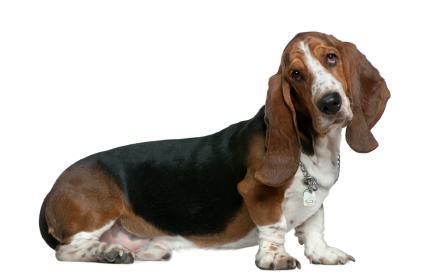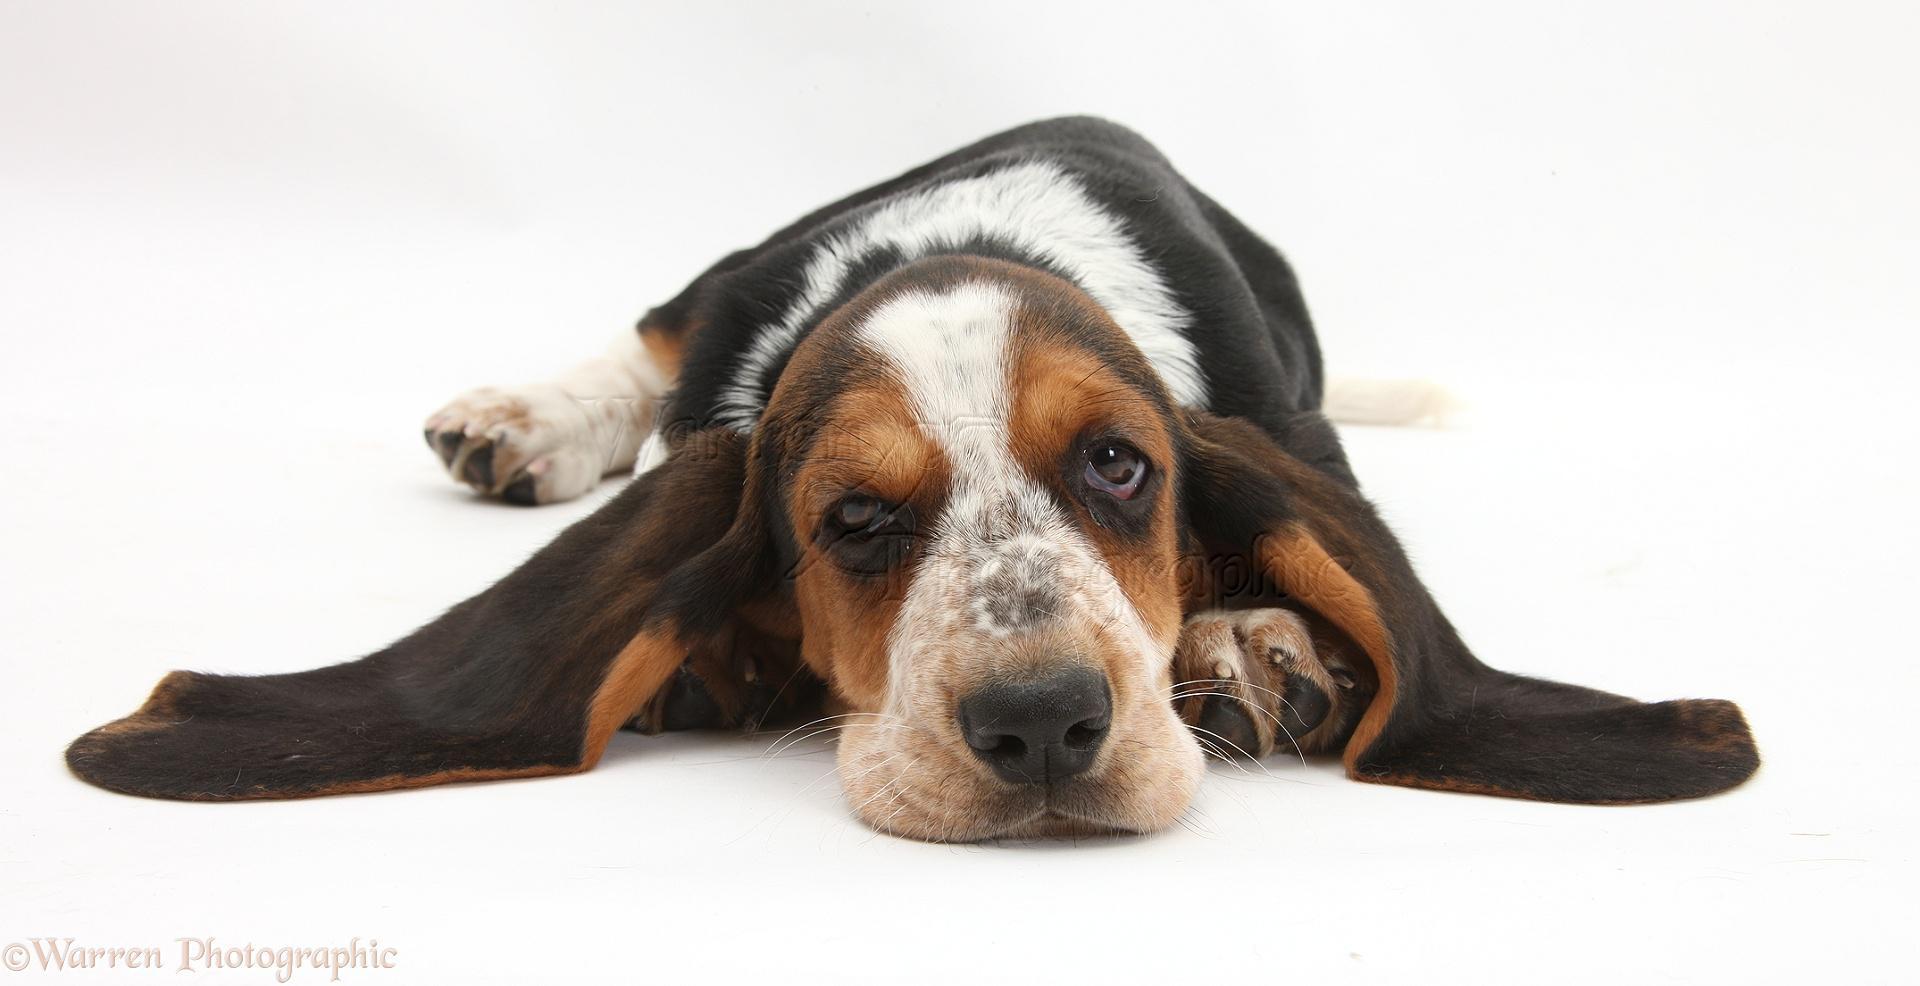The first image is the image on the left, the second image is the image on the right. Examine the images to the left and right. Is the description "The mouth of the dog in the image on the left is open." accurate? Answer yes or no. No. The first image is the image on the left, the second image is the image on the right. Examine the images to the left and right. Is the description "An image shows one forward-turned basset hound, which has its mouth open fairly wide." accurate? Answer yes or no. No. 